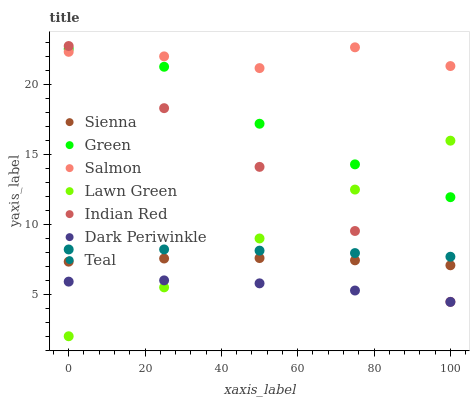Does Dark Periwinkle have the minimum area under the curve?
Answer yes or no. Yes. Does Salmon have the maximum area under the curve?
Answer yes or no. Yes. Does Teal have the minimum area under the curve?
Answer yes or no. No. Does Teal have the maximum area under the curve?
Answer yes or no. No. Is Lawn Green the smoothest?
Answer yes or no. Yes. Is Salmon the roughest?
Answer yes or no. Yes. Is Teal the smoothest?
Answer yes or no. No. Is Teal the roughest?
Answer yes or no. No. Does Lawn Green have the lowest value?
Answer yes or no. Yes. Does Teal have the lowest value?
Answer yes or no. No. Does Indian Red have the highest value?
Answer yes or no. Yes. Does Teal have the highest value?
Answer yes or no. No. Is Dark Periwinkle less than Salmon?
Answer yes or no. Yes. Is Salmon greater than Lawn Green?
Answer yes or no. Yes. Does Lawn Green intersect Green?
Answer yes or no. Yes. Is Lawn Green less than Green?
Answer yes or no. No. Is Lawn Green greater than Green?
Answer yes or no. No. Does Dark Periwinkle intersect Salmon?
Answer yes or no. No. 